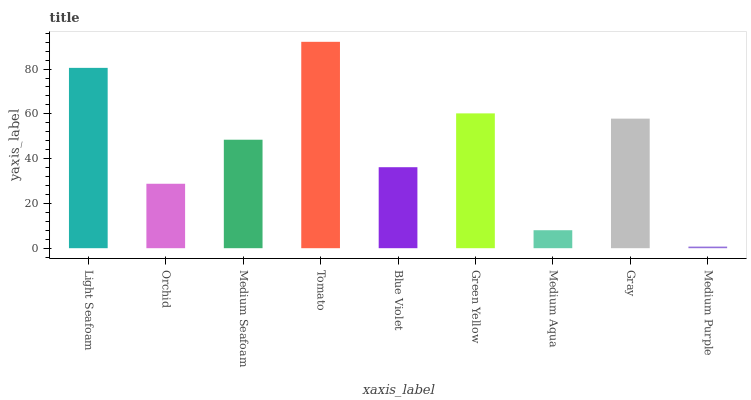Is Medium Purple the minimum?
Answer yes or no. Yes. Is Tomato the maximum?
Answer yes or no. Yes. Is Orchid the minimum?
Answer yes or no. No. Is Orchid the maximum?
Answer yes or no. No. Is Light Seafoam greater than Orchid?
Answer yes or no. Yes. Is Orchid less than Light Seafoam?
Answer yes or no. Yes. Is Orchid greater than Light Seafoam?
Answer yes or no. No. Is Light Seafoam less than Orchid?
Answer yes or no. No. Is Medium Seafoam the high median?
Answer yes or no. Yes. Is Medium Seafoam the low median?
Answer yes or no. Yes. Is Gray the high median?
Answer yes or no. No. Is Blue Violet the low median?
Answer yes or no. No. 